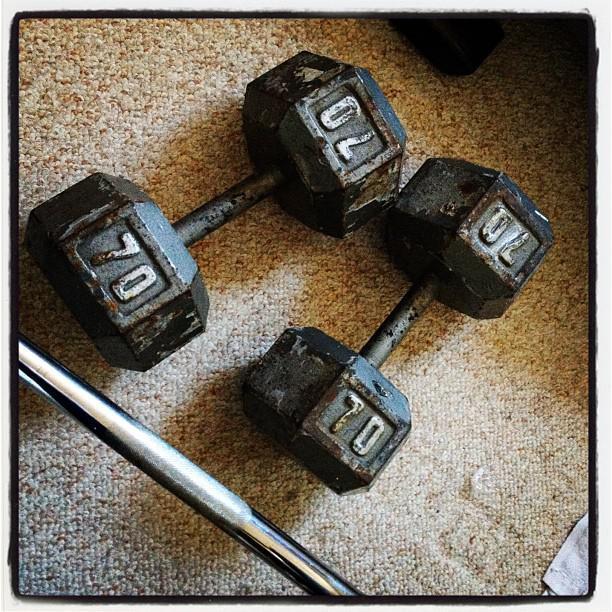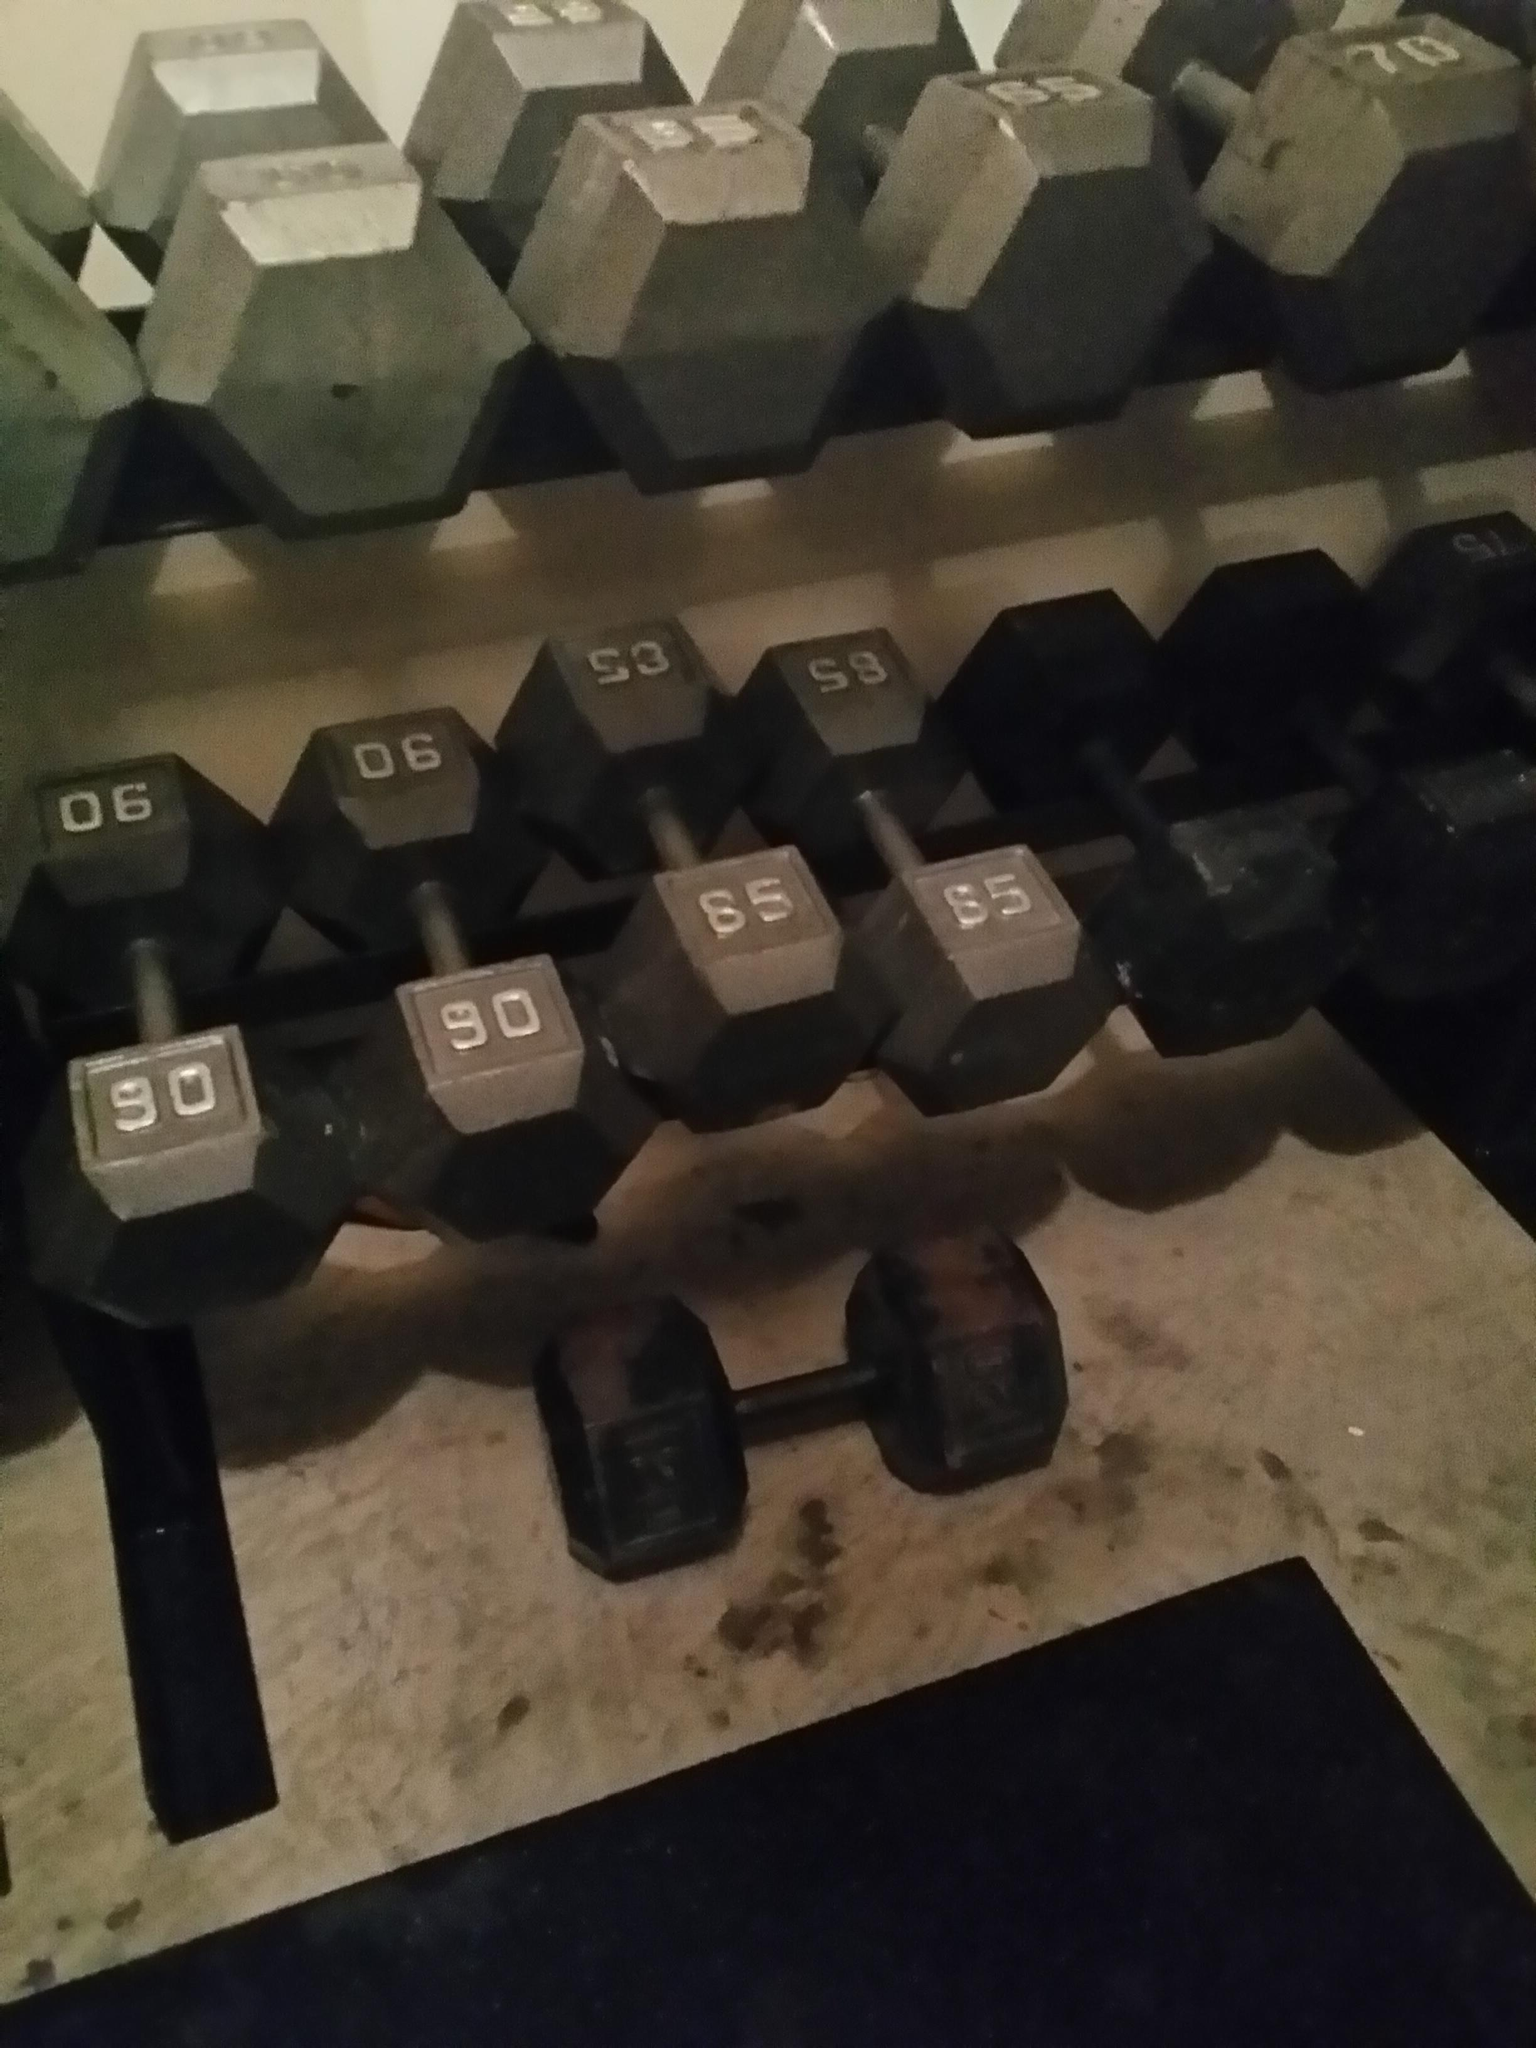The first image is the image on the left, the second image is the image on the right. Given the left and right images, does the statement "All of the weights are round." hold true? Answer yes or no. No. The first image is the image on the left, the second image is the image on the right. Given the left and right images, does the statement "One image shows exactly two dumbbells, and the other image shows a row of at least six dumbbells with faceted hexagon shaped ends." hold true? Answer yes or no. Yes. 